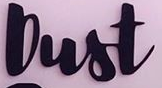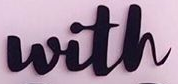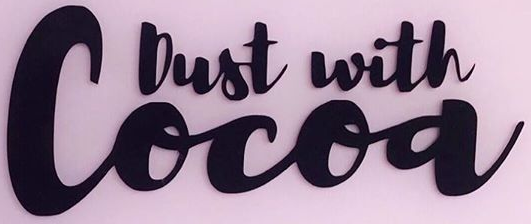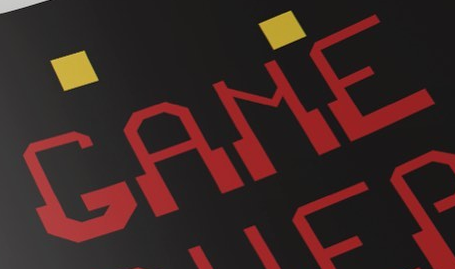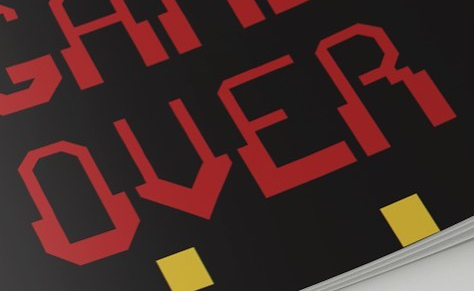Identify the words shown in these images in order, separated by a semicolon. Dust; with; Cocoa; GAME; OVER 